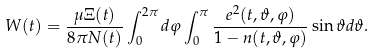<formula> <loc_0><loc_0><loc_500><loc_500>W ( t ) = \frac { \mu \Xi ( t ) } { 8 \pi N ( t ) } \int _ { 0 } ^ { 2 \pi } d \varphi \int _ { 0 } ^ { \pi } \frac { e ^ { 2 } ( t , \vartheta , \varphi ) } { 1 - n ( t , \vartheta , \varphi ) } \sin \vartheta d \vartheta .</formula> 